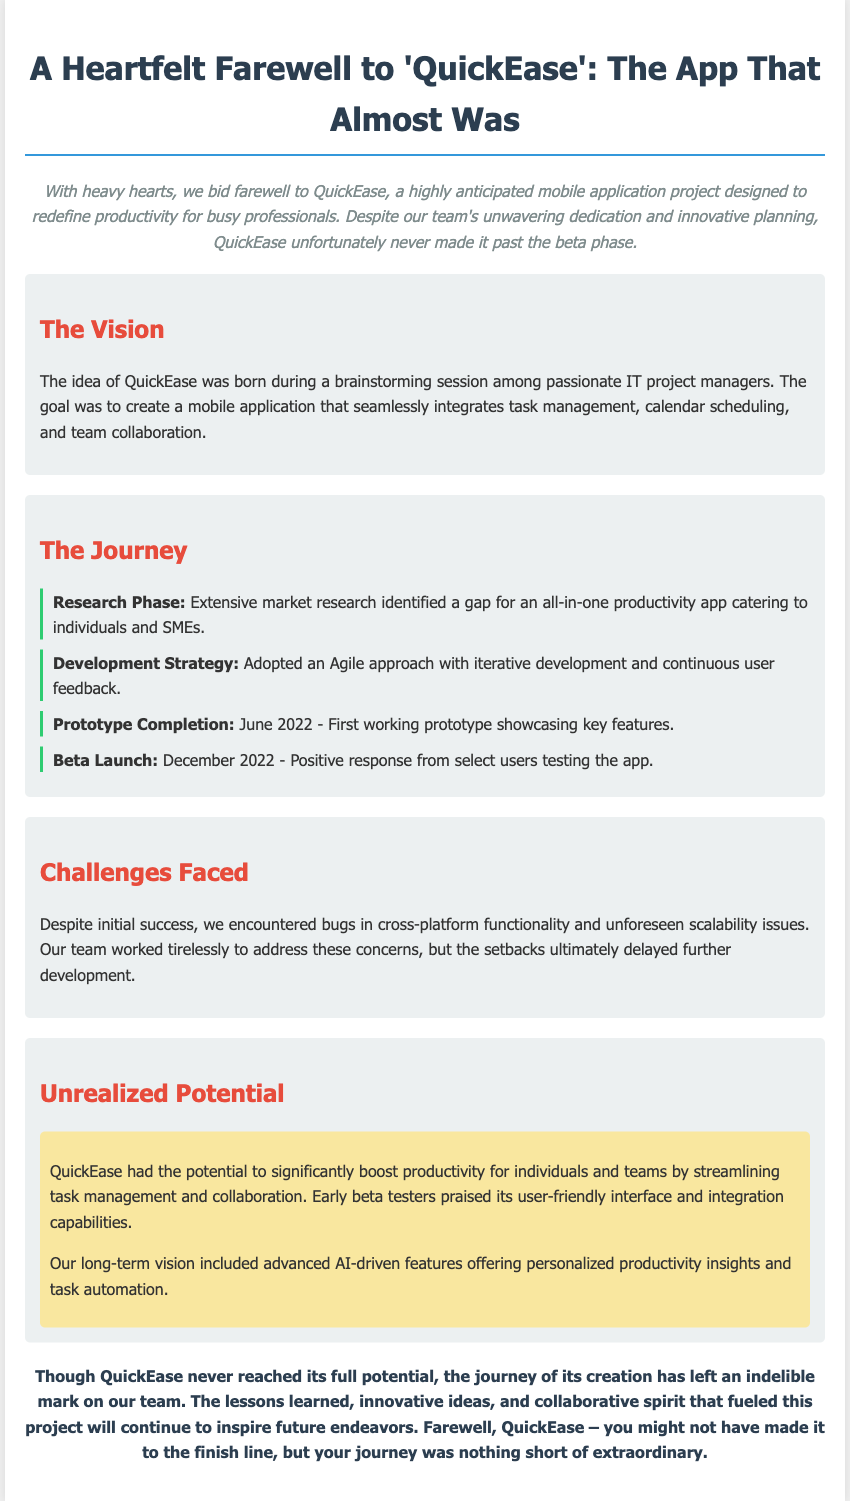What is the name of the mobile application project? The name of the project is mentioned in the title of the document.
Answer: QuickEase When did the beta launch occur? The beta launch date is specified in the journey section as the point when the app was tested by users.
Answer: December 2022 What was the first milestone completed in the project? The first completed milestone is detailed in the journey section, highlighting the prototype's development.
Answer: Prototype Completion Which approach was adopted for development? The development strategy is outlined in the journey section, indicating the method used for app development.
Answer: Agile approach What feature was praised by early beta testers? The document mentions a specific aspect that beta testers appreciated about the application.
Answer: User-friendly interface What major challenge did the team face? A significant issue that impacted the project is identified in the challenges section.
Answer: Bugs in cross-platform functionality What was the potential user impact of QuickEase? The unrealized potential describes how QuickEase could have benefited users if fully developed.
Answer: Boost productivity What was the team's long-term vision for QuickEase? The document outlines an aspirational feature set that the team hoped to implement.
Answer: Advanced AI-driven features What phrase describes the overall feelings about QuickEase's journey? The conclusion section encapsulates the sentiment towards the project's development experience.
Answer: Extraordinary 